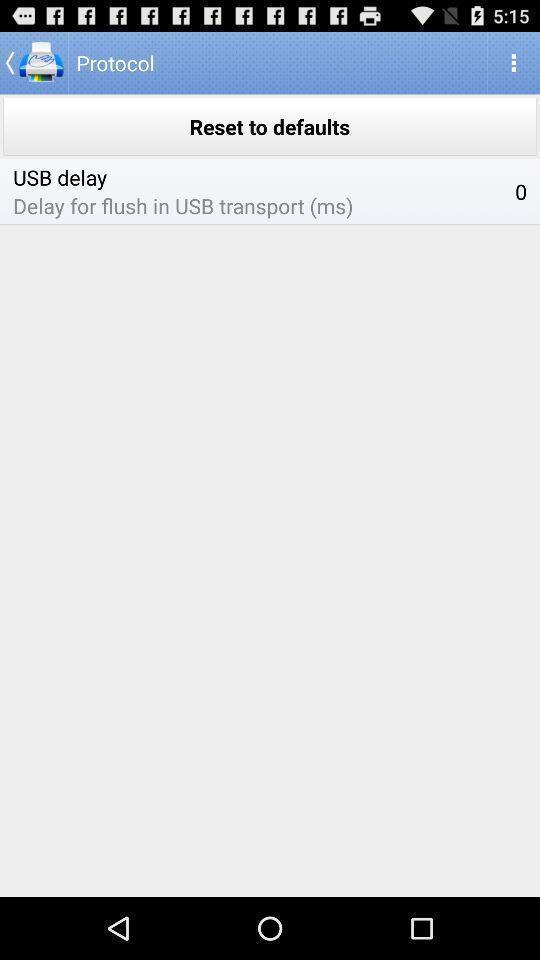Describe the content in this image. Screen displaying the protocol page. 